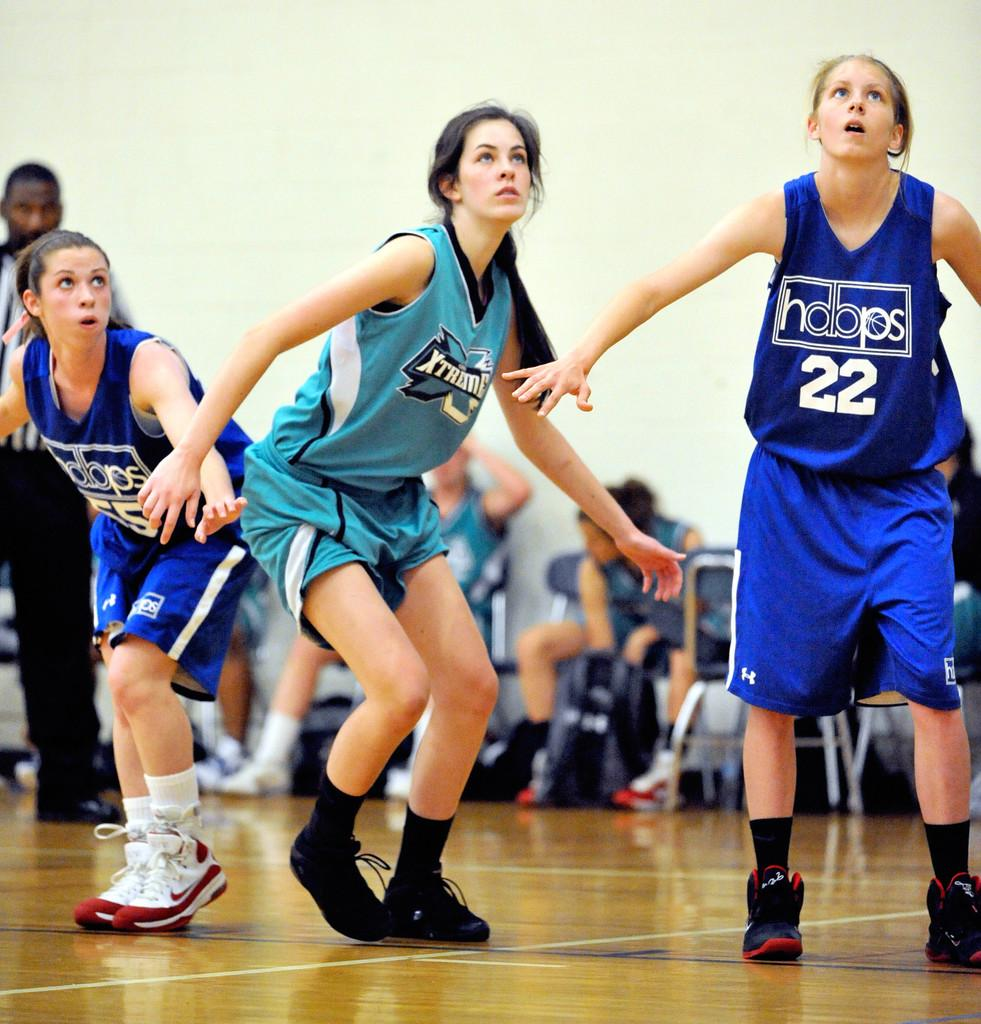<image>
Offer a succinct explanation of the picture presented. Basketball players looking at something with one wearing a number 22. 